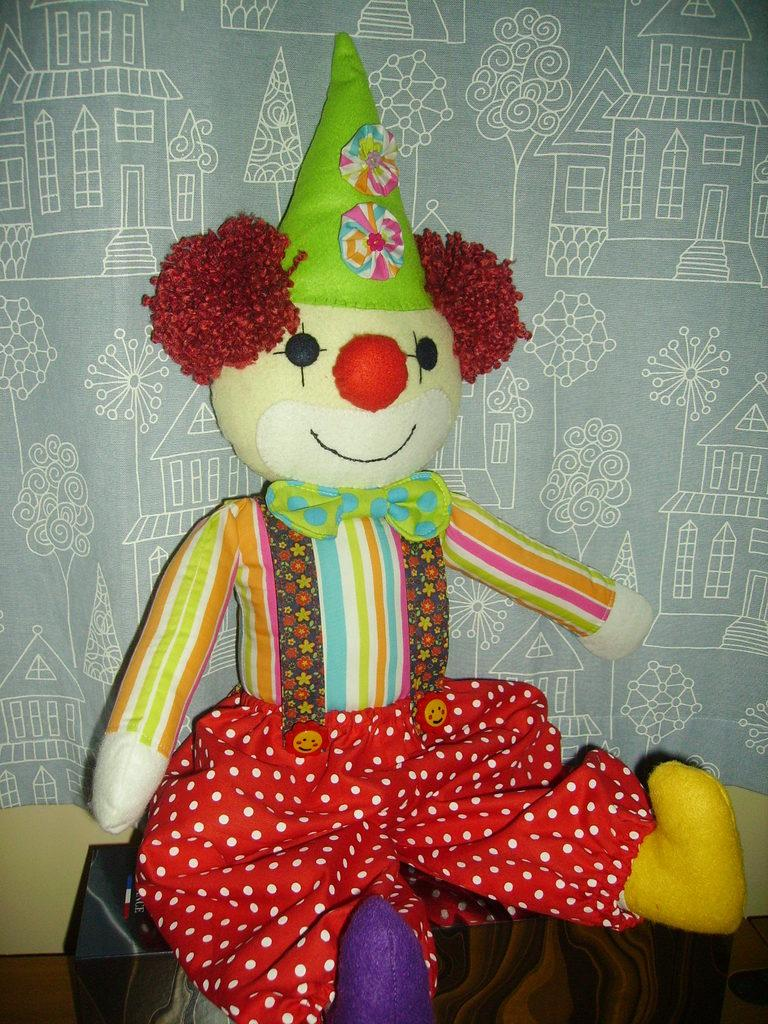What object is placed on the table in the image? There is a toy placed on a table in the image. Can you describe anything in the background of the image? There is a cloth in the background of the image. What type of profit can be seen growing in the image? There is no mention of profit or any type of plant in the image; it only features a toy placed on a table and a cloth in the background. 